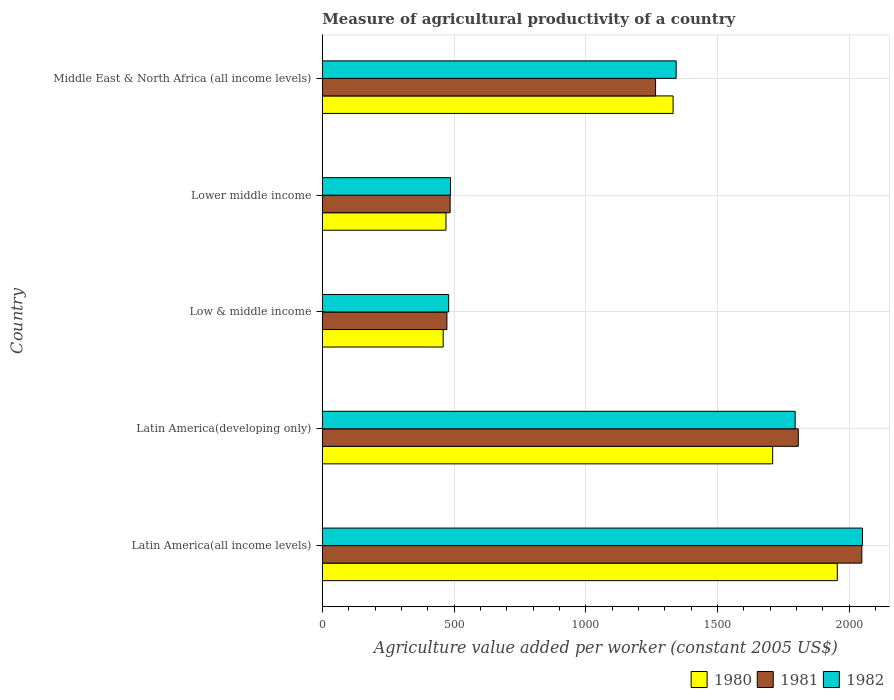Are the number of bars per tick equal to the number of legend labels?
Provide a succinct answer. Yes. How many bars are there on the 1st tick from the top?
Your response must be concise. 3. How many bars are there on the 5th tick from the bottom?
Your answer should be compact. 3. What is the label of the 1st group of bars from the top?
Keep it short and to the point. Middle East & North Africa (all income levels). In how many cases, is the number of bars for a given country not equal to the number of legend labels?
Offer a terse response. 0. What is the measure of agricultural productivity in 1982 in Low & middle income?
Your response must be concise. 479.69. Across all countries, what is the maximum measure of agricultural productivity in 1980?
Make the answer very short. 1955.34. Across all countries, what is the minimum measure of agricultural productivity in 1981?
Your response must be concise. 473.04. In which country was the measure of agricultural productivity in 1981 maximum?
Your answer should be very brief. Latin America(all income levels). What is the total measure of agricultural productivity in 1981 in the graph?
Ensure brevity in your answer.  6079.52. What is the difference between the measure of agricultural productivity in 1980 in Low & middle income and that in Middle East & North Africa (all income levels)?
Give a very brief answer. -872.97. What is the difference between the measure of agricultural productivity in 1981 in Latin America(all income levels) and the measure of agricultural productivity in 1982 in Middle East & North Africa (all income levels)?
Your response must be concise. 705.04. What is the average measure of agricultural productivity in 1981 per country?
Make the answer very short. 1215.9. What is the difference between the measure of agricultural productivity in 1981 and measure of agricultural productivity in 1982 in Middle East & North Africa (all income levels)?
Give a very brief answer. -78.18. In how many countries, is the measure of agricultural productivity in 1981 greater than 1700 US$?
Your response must be concise. 2. What is the ratio of the measure of agricultural productivity in 1982 in Latin America(all income levels) to that in Lower middle income?
Your answer should be compact. 4.21. What is the difference between the highest and the second highest measure of agricultural productivity in 1982?
Ensure brevity in your answer.  255.62. What is the difference between the highest and the lowest measure of agricultural productivity in 1982?
Your answer should be very brief. 1571.31. In how many countries, is the measure of agricultural productivity in 1981 greater than the average measure of agricultural productivity in 1981 taken over all countries?
Provide a succinct answer. 3. Is the sum of the measure of agricultural productivity in 1982 in Latin America(all income levels) and Lower middle income greater than the maximum measure of agricultural productivity in 1980 across all countries?
Your answer should be very brief. Yes. Is it the case that in every country, the sum of the measure of agricultural productivity in 1982 and measure of agricultural productivity in 1981 is greater than the measure of agricultural productivity in 1980?
Offer a very short reply. Yes. How many bars are there?
Keep it short and to the point. 15. How are the legend labels stacked?
Offer a terse response. Horizontal. What is the title of the graph?
Provide a short and direct response. Measure of agricultural productivity of a country. Does "1981" appear as one of the legend labels in the graph?
Provide a short and direct response. Yes. What is the label or title of the X-axis?
Your response must be concise. Agriculture value added per worker (constant 2005 US$). What is the label or title of the Y-axis?
Ensure brevity in your answer.  Country. What is the Agriculture value added per worker (constant 2005 US$) in 1980 in Latin America(all income levels)?
Your answer should be compact. 1955.34. What is the Agriculture value added per worker (constant 2005 US$) in 1981 in Latin America(all income levels)?
Your response must be concise. 2048.57. What is the Agriculture value added per worker (constant 2005 US$) of 1982 in Latin America(all income levels)?
Offer a very short reply. 2051.01. What is the Agriculture value added per worker (constant 2005 US$) in 1980 in Latin America(developing only)?
Offer a terse response. 1709.94. What is the Agriculture value added per worker (constant 2005 US$) of 1981 in Latin America(developing only)?
Your response must be concise. 1807.22. What is the Agriculture value added per worker (constant 2005 US$) in 1982 in Latin America(developing only)?
Provide a succinct answer. 1795.38. What is the Agriculture value added per worker (constant 2005 US$) of 1980 in Low & middle income?
Your answer should be compact. 458.89. What is the Agriculture value added per worker (constant 2005 US$) in 1981 in Low & middle income?
Your answer should be compact. 473.04. What is the Agriculture value added per worker (constant 2005 US$) in 1982 in Low & middle income?
Make the answer very short. 479.69. What is the Agriculture value added per worker (constant 2005 US$) in 1980 in Lower middle income?
Ensure brevity in your answer.  469.51. What is the Agriculture value added per worker (constant 2005 US$) of 1981 in Lower middle income?
Your answer should be compact. 485.33. What is the Agriculture value added per worker (constant 2005 US$) in 1982 in Lower middle income?
Provide a short and direct response. 486.74. What is the Agriculture value added per worker (constant 2005 US$) in 1980 in Middle East & North Africa (all income levels)?
Your response must be concise. 1331.86. What is the Agriculture value added per worker (constant 2005 US$) in 1981 in Middle East & North Africa (all income levels)?
Offer a very short reply. 1265.35. What is the Agriculture value added per worker (constant 2005 US$) in 1982 in Middle East & North Africa (all income levels)?
Your answer should be very brief. 1343.53. Across all countries, what is the maximum Agriculture value added per worker (constant 2005 US$) of 1980?
Keep it short and to the point. 1955.34. Across all countries, what is the maximum Agriculture value added per worker (constant 2005 US$) of 1981?
Provide a short and direct response. 2048.57. Across all countries, what is the maximum Agriculture value added per worker (constant 2005 US$) of 1982?
Your answer should be compact. 2051.01. Across all countries, what is the minimum Agriculture value added per worker (constant 2005 US$) in 1980?
Offer a terse response. 458.89. Across all countries, what is the minimum Agriculture value added per worker (constant 2005 US$) of 1981?
Give a very brief answer. 473.04. Across all countries, what is the minimum Agriculture value added per worker (constant 2005 US$) in 1982?
Provide a short and direct response. 479.69. What is the total Agriculture value added per worker (constant 2005 US$) of 1980 in the graph?
Provide a short and direct response. 5925.55. What is the total Agriculture value added per worker (constant 2005 US$) in 1981 in the graph?
Provide a short and direct response. 6079.52. What is the total Agriculture value added per worker (constant 2005 US$) in 1982 in the graph?
Your response must be concise. 6156.35. What is the difference between the Agriculture value added per worker (constant 2005 US$) of 1980 in Latin America(all income levels) and that in Latin America(developing only)?
Ensure brevity in your answer.  245.39. What is the difference between the Agriculture value added per worker (constant 2005 US$) in 1981 in Latin America(all income levels) and that in Latin America(developing only)?
Give a very brief answer. 241.34. What is the difference between the Agriculture value added per worker (constant 2005 US$) of 1982 in Latin America(all income levels) and that in Latin America(developing only)?
Your answer should be very brief. 255.62. What is the difference between the Agriculture value added per worker (constant 2005 US$) in 1980 in Latin America(all income levels) and that in Low & middle income?
Give a very brief answer. 1496.45. What is the difference between the Agriculture value added per worker (constant 2005 US$) of 1981 in Latin America(all income levels) and that in Low & middle income?
Offer a terse response. 1575.53. What is the difference between the Agriculture value added per worker (constant 2005 US$) of 1982 in Latin America(all income levels) and that in Low & middle income?
Provide a short and direct response. 1571.31. What is the difference between the Agriculture value added per worker (constant 2005 US$) of 1980 in Latin America(all income levels) and that in Lower middle income?
Keep it short and to the point. 1485.83. What is the difference between the Agriculture value added per worker (constant 2005 US$) in 1981 in Latin America(all income levels) and that in Lower middle income?
Provide a succinct answer. 1563.23. What is the difference between the Agriculture value added per worker (constant 2005 US$) of 1982 in Latin America(all income levels) and that in Lower middle income?
Offer a terse response. 1564.27. What is the difference between the Agriculture value added per worker (constant 2005 US$) of 1980 in Latin America(all income levels) and that in Middle East & North Africa (all income levels)?
Offer a terse response. 623.48. What is the difference between the Agriculture value added per worker (constant 2005 US$) of 1981 in Latin America(all income levels) and that in Middle East & North Africa (all income levels)?
Your answer should be compact. 783.21. What is the difference between the Agriculture value added per worker (constant 2005 US$) of 1982 in Latin America(all income levels) and that in Middle East & North Africa (all income levels)?
Give a very brief answer. 707.48. What is the difference between the Agriculture value added per worker (constant 2005 US$) of 1980 in Latin America(developing only) and that in Low & middle income?
Provide a short and direct response. 1251.05. What is the difference between the Agriculture value added per worker (constant 2005 US$) of 1981 in Latin America(developing only) and that in Low & middle income?
Your response must be concise. 1334.18. What is the difference between the Agriculture value added per worker (constant 2005 US$) of 1982 in Latin America(developing only) and that in Low & middle income?
Your answer should be compact. 1315.69. What is the difference between the Agriculture value added per worker (constant 2005 US$) in 1980 in Latin America(developing only) and that in Lower middle income?
Offer a terse response. 1240.43. What is the difference between the Agriculture value added per worker (constant 2005 US$) of 1981 in Latin America(developing only) and that in Lower middle income?
Make the answer very short. 1321.89. What is the difference between the Agriculture value added per worker (constant 2005 US$) of 1982 in Latin America(developing only) and that in Lower middle income?
Your answer should be very brief. 1308.65. What is the difference between the Agriculture value added per worker (constant 2005 US$) in 1980 in Latin America(developing only) and that in Middle East & North Africa (all income levels)?
Make the answer very short. 378.08. What is the difference between the Agriculture value added per worker (constant 2005 US$) in 1981 in Latin America(developing only) and that in Middle East & North Africa (all income levels)?
Your response must be concise. 541.87. What is the difference between the Agriculture value added per worker (constant 2005 US$) of 1982 in Latin America(developing only) and that in Middle East & North Africa (all income levels)?
Give a very brief answer. 451.85. What is the difference between the Agriculture value added per worker (constant 2005 US$) in 1980 in Low & middle income and that in Lower middle income?
Your response must be concise. -10.62. What is the difference between the Agriculture value added per worker (constant 2005 US$) of 1981 in Low & middle income and that in Lower middle income?
Give a very brief answer. -12.29. What is the difference between the Agriculture value added per worker (constant 2005 US$) of 1982 in Low & middle income and that in Lower middle income?
Keep it short and to the point. -7.05. What is the difference between the Agriculture value added per worker (constant 2005 US$) of 1980 in Low & middle income and that in Middle East & North Africa (all income levels)?
Make the answer very short. -872.97. What is the difference between the Agriculture value added per worker (constant 2005 US$) of 1981 in Low & middle income and that in Middle East & North Africa (all income levels)?
Offer a terse response. -792.31. What is the difference between the Agriculture value added per worker (constant 2005 US$) in 1982 in Low & middle income and that in Middle East & North Africa (all income levels)?
Give a very brief answer. -863.84. What is the difference between the Agriculture value added per worker (constant 2005 US$) of 1980 in Lower middle income and that in Middle East & North Africa (all income levels)?
Your response must be concise. -862.35. What is the difference between the Agriculture value added per worker (constant 2005 US$) in 1981 in Lower middle income and that in Middle East & North Africa (all income levels)?
Offer a terse response. -780.02. What is the difference between the Agriculture value added per worker (constant 2005 US$) of 1982 in Lower middle income and that in Middle East & North Africa (all income levels)?
Provide a succinct answer. -856.79. What is the difference between the Agriculture value added per worker (constant 2005 US$) in 1980 in Latin America(all income levels) and the Agriculture value added per worker (constant 2005 US$) in 1981 in Latin America(developing only)?
Keep it short and to the point. 148.11. What is the difference between the Agriculture value added per worker (constant 2005 US$) in 1980 in Latin America(all income levels) and the Agriculture value added per worker (constant 2005 US$) in 1982 in Latin America(developing only)?
Ensure brevity in your answer.  159.95. What is the difference between the Agriculture value added per worker (constant 2005 US$) in 1981 in Latin America(all income levels) and the Agriculture value added per worker (constant 2005 US$) in 1982 in Latin America(developing only)?
Offer a terse response. 253.18. What is the difference between the Agriculture value added per worker (constant 2005 US$) in 1980 in Latin America(all income levels) and the Agriculture value added per worker (constant 2005 US$) in 1981 in Low & middle income?
Your response must be concise. 1482.3. What is the difference between the Agriculture value added per worker (constant 2005 US$) in 1980 in Latin America(all income levels) and the Agriculture value added per worker (constant 2005 US$) in 1982 in Low & middle income?
Provide a short and direct response. 1475.65. What is the difference between the Agriculture value added per worker (constant 2005 US$) in 1981 in Latin America(all income levels) and the Agriculture value added per worker (constant 2005 US$) in 1982 in Low & middle income?
Provide a succinct answer. 1568.87. What is the difference between the Agriculture value added per worker (constant 2005 US$) of 1980 in Latin America(all income levels) and the Agriculture value added per worker (constant 2005 US$) of 1981 in Lower middle income?
Your response must be concise. 1470. What is the difference between the Agriculture value added per worker (constant 2005 US$) of 1980 in Latin America(all income levels) and the Agriculture value added per worker (constant 2005 US$) of 1982 in Lower middle income?
Ensure brevity in your answer.  1468.6. What is the difference between the Agriculture value added per worker (constant 2005 US$) in 1981 in Latin America(all income levels) and the Agriculture value added per worker (constant 2005 US$) in 1982 in Lower middle income?
Ensure brevity in your answer.  1561.83. What is the difference between the Agriculture value added per worker (constant 2005 US$) in 1980 in Latin America(all income levels) and the Agriculture value added per worker (constant 2005 US$) in 1981 in Middle East & North Africa (all income levels)?
Provide a short and direct response. 689.98. What is the difference between the Agriculture value added per worker (constant 2005 US$) of 1980 in Latin America(all income levels) and the Agriculture value added per worker (constant 2005 US$) of 1982 in Middle East & North Africa (all income levels)?
Keep it short and to the point. 611.81. What is the difference between the Agriculture value added per worker (constant 2005 US$) in 1981 in Latin America(all income levels) and the Agriculture value added per worker (constant 2005 US$) in 1982 in Middle East & North Africa (all income levels)?
Offer a terse response. 705.04. What is the difference between the Agriculture value added per worker (constant 2005 US$) of 1980 in Latin America(developing only) and the Agriculture value added per worker (constant 2005 US$) of 1981 in Low & middle income?
Your answer should be compact. 1236.9. What is the difference between the Agriculture value added per worker (constant 2005 US$) of 1980 in Latin America(developing only) and the Agriculture value added per worker (constant 2005 US$) of 1982 in Low & middle income?
Provide a short and direct response. 1230.25. What is the difference between the Agriculture value added per worker (constant 2005 US$) in 1981 in Latin America(developing only) and the Agriculture value added per worker (constant 2005 US$) in 1982 in Low & middle income?
Provide a succinct answer. 1327.53. What is the difference between the Agriculture value added per worker (constant 2005 US$) in 1980 in Latin America(developing only) and the Agriculture value added per worker (constant 2005 US$) in 1981 in Lower middle income?
Provide a succinct answer. 1224.61. What is the difference between the Agriculture value added per worker (constant 2005 US$) in 1980 in Latin America(developing only) and the Agriculture value added per worker (constant 2005 US$) in 1982 in Lower middle income?
Give a very brief answer. 1223.21. What is the difference between the Agriculture value added per worker (constant 2005 US$) of 1981 in Latin America(developing only) and the Agriculture value added per worker (constant 2005 US$) of 1982 in Lower middle income?
Make the answer very short. 1320.49. What is the difference between the Agriculture value added per worker (constant 2005 US$) of 1980 in Latin America(developing only) and the Agriculture value added per worker (constant 2005 US$) of 1981 in Middle East & North Africa (all income levels)?
Ensure brevity in your answer.  444.59. What is the difference between the Agriculture value added per worker (constant 2005 US$) in 1980 in Latin America(developing only) and the Agriculture value added per worker (constant 2005 US$) in 1982 in Middle East & North Africa (all income levels)?
Give a very brief answer. 366.42. What is the difference between the Agriculture value added per worker (constant 2005 US$) in 1981 in Latin America(developing only) and the Agriculture value added per worker (constant 2005 US$) in 1982 in Middle East & North Africa (all income levels)?
Ensure brevity in your answer.  463.69. What is the difference between the Agriculture value added per worker (constant 2005 US$) of 1980 in Low & middle income and the Agriculture value added per worker (constant 2005 US$) of 1981 in Lower middle income?
Provide a succinct answer. -26.44. What is the difference between the Agriculture value added per worker (constant 2005 US$) of 1980 in Low & middle income and the Agriculture value added per worker (constant 2005 US$) of 1982 in Lower middle income?
Provide a short and direct response. -27.85. What is the difference between the Agriculture value added per worker (constant 2005 US$) in 1981 in Low & middle income and the Agriculture value added per worker (constant 2005 US$) in 1982 in Lower middle income?
Offer a very short reply. -13.7. What is the difference between the Agriculture value added per worker (constant 2005 US$) of 1980 in Low & middle income and the Agriculture value added per worker (constant 2005 US$) of 1981 in Middle East & North Africa (all income levels)?
Your answer should be compact. -806.46. What is the difference between the Agriculture value added per worker (constant 2005 US$) of 1980 in Low & middle income and the Agriculture value added per worker (constant 2005 US$) of 1982 in Middle East & North Africa (all income levels)?
Ensure brevity in your answer.  -884.64. What is the difference between the Agriculture value added per worker (constant 2005 US$) in 1981 in Low & middle income and the Agriculture value added per worker (constant 2005 US$) in 1982 in Middle East & North Africa (all income levels)?
Your answer should be compact. -870.49. What is the difference between the Agriculture value added per worker (constant 2005 US$) in 1980 in Lower middle income and the Agriculture value added per worker (constant 2005 US$) in 1981 in Middle East & North Africa (all income levels)?
Make the answer very short. -795.84. What is the difference between the Agriculture value added per worker (constant 2005 US$) in 1980 in Lower middle income and the Agriculture value added per worker (constant 2005 US$) in 1982 in Middle East & North Africa (all income levels)?
Ensure brevity in your answer.  -874.02. What is the difference between the Agriculture value added per worker (constant 2005 US$) of 1981 in Lower middle income and the Agriculture value added per worker (constant 2005 US$) of 1982 in Middle East & North Africa (all income levels)?
Provide a short and direct response. -858.2. What is the average Agriculture value added per worker (constant 2005 US$) of 1980 per country?
Ensure brevity in your answer.  1185.11. What is the average Agriculture value added per worker (constant 2005 US$) in 1981 per country?
Your answer should be very brief. 1215.9. What is the average Agriculture value added per worker (constant 2005 US$) in 1982 per country?
Offer a very short reply. 1231.27. What is the difference between the Agriculture value added per worker (constant 2005 US$) in 1980 and Agriculture value added per worker (constant 2005 US$) in 1981 in Latin America(all income levels)?
Make the answer very short. -93.23. What is the difference between the Agriculture value added per worker (constant 2005 US$) in 1980 and Agriculture value added per worker (constant 2005 US$) in 1982 in Latin America(all income levels)?
Offer a terse response. -95.67. What is the difference between the Agriculture value added per worker (constant 2005 US$) of 1981 and Agriculture value added per worker (constant 2005 US$) of 1982 in Latin America(all income levels)?
Your answer should be compact. -2.44. What is the difference between the Agriculture value added per worker (constant 2005 US$) of 1980 and Agriculture value added per worker (constant 2005 US$) of 1981 in Latin America(developing only)?
Keep it short and to the point. -97.28. What is the difference between the Agriculture value added per worker (constant 2005 US$) of 1980 and Agriculture value added per worker (constant 2005 US$) of 1982 in Latin America(developing only)?
Offer a terse response. -85.44. What is the difference between the Agriculture value added per worker (constant 2005 US$) of 1981 and Agriculture value added per worker (constant 2005 US$) of 1982 in Latin America(developing only)?
Give a very brief answer. 11.84. What is the difference between the Agriculture value added per worker (constant 2005 US$) in 1980 and Agriculture value added per worker (constant 2005 US$) in 1981 in Low & middle income?
Offer a terse response. -14.15. What is the difference between the Agriculture value added per worker (constant 2005 US$) of 1980 and Agriculture value added per worker (constant 2005 US$) of 1982 in Low & middle income?
Keep it short and to the point. -20.8. What is the difference between the Agriculture value added per worker (constant 2005 US$) in 1981 and Agriculture value added per worker (constant 2005 US$) in 1982 in Low & middle income?
Provide a succinct answer. -6.65. What is the difference between the Agriculture value added per worker (constant 2005 US$) in 1980 and Agriculture value added per worker (constant 2005 US$) in 1981 in Lower middle income?
Your response must be concise. -15.82. What is the difference between the Agriculture value added per worker (constant 2005 US$) in 1980 and Agriculture value added per worker (constant 2005 US$) in 1982 in Lower middle income?
Your answer should be compact. -17.23. What is the difference between the Agriculture value added per worker (constant 2005 US$) of 1981 and Agriculture value added per worker (constant 2005 US$) of 1982 in Lower middle income?
Provide a succinct answer. -1.4. What is the difference between the Agriculture value added per worker (constant 2005 US$) in 1980 and Agriculture value added per worker (constant 2005 US$) in 1981 in Middle East & North Africa (all income levels)?
Your answer should be compact. 66.51. What is the difference between the Agriculture value added per worker (constant 2005 US$) in 1980 and Agriculture value added per worker (constant 2005 US$) in 1982 in Middle East & North Africa (all income levels)?
Keep it short and to the point. -11.67. What is the difference between the Agriculture value added per worker (constant 2005 US$) of 1981 and Agriculture value added per worker (constant 2005 US$) of 1982 in Middle East & North Africa (all income levels)?
Give a very brief answer. -78.18. What is the ratio of the Agriculture value added per worker (constant 2005 US$) in 1980 in Latin America(all income levels) to that in Latin America(developing only)?
Offer a very short reply. 1.14. What is the ratio of the Agriculture value added per worker (constant 2005 US$) in 1981 in Latin America(all income levels) to that in Latin America(developing only)?
Offer a terse response. 1.13. What is the ratio of the Agriculture value added per worker (constant 2005 US$) of 1982 in Latin America(all income levels) to that in Latin America(developing only)?
Keep it short and to the point. 1.14. What is the ratio of the Agriculture value added per worker (constant 2005 US$) of 1980 in Latin America(all income levels) to that in Low & middle income?
Your response must be concise. 4.26. What is the ratio of the Agriculture value added per worker (constant 2005 US$) of 1981 in Latin America(all income levels) to that in Low & middle income?
Keep it short and to the point. 4.33. What is the ratio of the Agriculture value added per worker (constant 2005 US$) in 1982 in Latin America(all income levels) to that in Low & middle income?
Your answer should be very brief. 4.28. What is the ratio of the Agriculture value added per worker (constant 2005 US$) in 1980 in Latin America(all income levels) to that in Lower middle income?
Keep it short and to the point. 4.16. What is the ratio of the Agriculture value added per worker (constant 2005 US$) of 1981 in Latin America(all income levels) to that in Lower middle income?
Provide a succinct answer. 4.22. What is the ratio of the Agriculture value added per worker (constant 2005 US$) of 1982 in Latin America(all income levels) to that in Lower middle income?
Keep it short and to the point. 4.21. What is the ratio of the Agriculture value added per worker (constant 2005 US$) of 1980 in Latin America(all income levels) to that in Middle East & North Africa (all income levels)?
Ensure brevity in your answer.  1.47. What is the ratio of the Agriculture value added per worker (constant 2005 US$) in 1981 in Latin America(all income levels) to that in Middle East & North Africa (all income levels)?
Your response must be concise. 1.62. What is the ratio of the Agriculture value added per worker (constant 2005 US$) in 1982 in Latin America(all income levels) to that in Middle East & North Africa (all income levels)?
Your response must be concise. 1.53. What is the ratio of the Agriculture value added per worker (constant 2005 US$) of 1980 in Latin America(developing only) to that in Low & middle income?
Provide a succinct answer. 3.73. What is the ratio of the Agriculture value added per worker (constant 2005 US$) in 1981 in Latin America(developing only) to that in Low & middle income?
Your response must be concise. 3.82. What is the ratio of the Agriculture value added per worker (constant 2005 US$) in 1982 in Latin America(developing only) to that in Low & middle income?
Your answer should be compact. 3.74. What is the ratio of the Agriculture value added per worker (constant 2005 US$) of 1980 in Latin America(developing only) to that in Lower middle income?
Make the answer very short. 3.64. What is the ratio of the Agriculture value added per worker (constant 2005 US$) of 1981 in Latin America(developing only) to that in Lower middle income?
Give a very brief answer. 3.72. What is the ratio of the Agriculture value added per worker (constant 2005 US$) in 1982 in Latin America(developing only) to that in Lower middle income?
Your answer should be very brief. 3.69. What is the ratio of the Agriculture value added per worker (constant 2005 US$) of 1980 in Latin America(developing only) to that in Middle East & North Africa (all income levels)?
Your answer should be very brief. 1.28. What is the ratio of the Agriculture value added per worker (constant 2005 US$) in 1981 in Latin America(developing only) to that in Middle East & North Africa (all income levels)?
Ensure brevity in your answer.  1.43. What is the ratio of the Agriculture value added per worker (constant 2005 US$) in 1982 in Latin America(developing only) to that in Middle East & North Africa (all income levels)?
Make the answer very short. 1.34. What is the ratio of the Agriculture value added per worker (constant 2005 US$) of 1980 in Low & middle income to that in Lower middle income?
Your answer should be compact. 0.98. What is the ratio of the Agriculture value added per worker (constant 2005 US$) in 1981 in Low & middle income to that in Lower middle income?
Your answer should be compact. 0.97. What is the ratio of the Agriculture value added per worker (constant 2005 US$) of 1982 in Low & middle income to that in Lower middle income?
Provide a succinct answer. 0.99. What is the ratio of the Agriculture value added per worker (constant 2005 US$) in 1980 in Low & middle income to that in Middle East & North Africa (all income levels)?
Offer a very short reply. 0.34. What is the ratio of the Agriculture value added per worker (constant 2005 US$) in 1981 in Low & middle income to that in Middle East & North Africa (all income levels)?
Your response must be concise. 0.37. What is the ratio of the Agriculture value added per worker (constant 2005 US$) in 1982 in Low & middle income to that in Middle East & North Africa (all income levels)?
Provide a succinct answer. 0.36. What is the ratio of the Agriculture value added per worker (constant 2005 US$) of 1980 in Lower middle income to that in Middle East & North Africa (all income levels)?
Keep it short and to the point. 0.35. What is the ratio of the Agriculture value added per worker (constant 2005 US$) of 1981 in Lower middle income to that in Middle East & North Africa (all income levels)?
Keep it short and to the point. 0.38. What is the ratio of the Agriculture value added per worker (constant 2005 US$) in 1982 in Lower middle income to that in Middle East & North Africa (all income levels)?
Offer a very short reply. 0.36. What is the difference between the highest and the second highest Agriculture value added per worker (constant 2005 US$) of 1980?
Your answer should be compact. 245.39. What is the difference between the highest and the second highest Agriculture value added per worker (constant 2005 US$) of 1981?
Provide a succinct answer. 241.34. What is the difference between the highest and the second highest Agriculture value added per worker (constant 2005 US$) of 1982?
Ensure brevity in your answer.  255.62. What is the difference between the highest and the lowest Agriculture value added per worker (constant 2005 US$) in 1980?
Offer a very short reply. 1496.45. What is the difference between the highest and the lowest Agriculture value added per worker (constant 2005 US$) of 1981?
Offer a very short reply. 1575.53. What is the difference between the highest and the lowest Agriculture value added per worker (constant 2005 US$) in 1982?
Ensure brevity in your answer.  1571.31. 